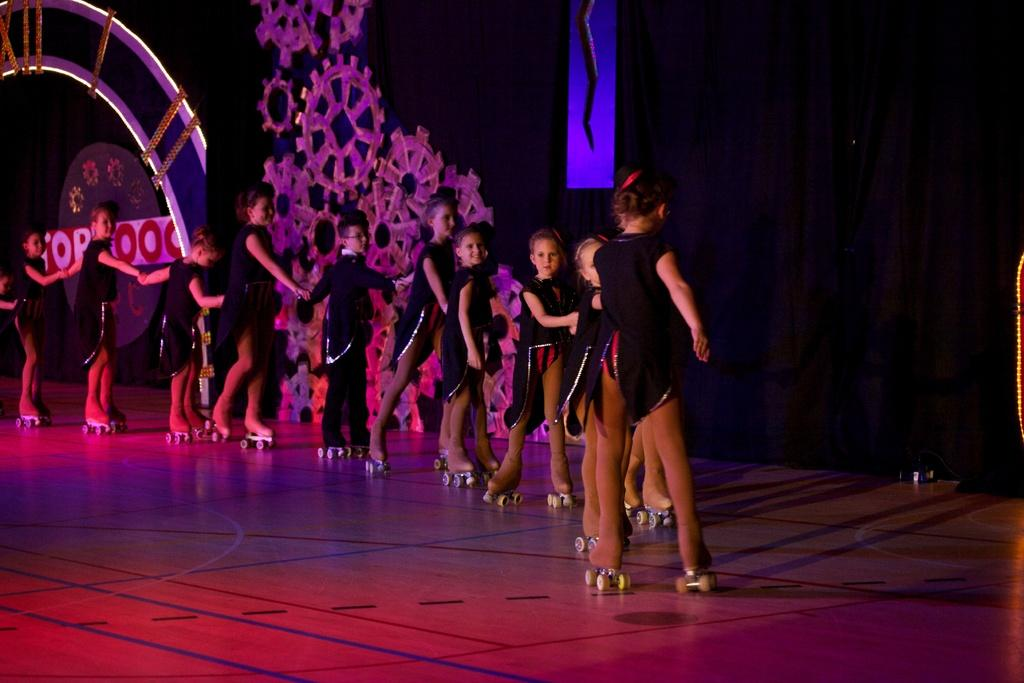What is the main subject of the image? The main subject of the image is a group of children. How are the children arranged in the image? The children are standing in a line. What are the children wearing in the image? The children are wearing black dresses and skate shoes. What can be inferred about the setting of the image? The setting appears to be a stage. What type of pipe can be seen in the background of the image? There is no pipe visible in the background of the image. What advice can be given to the children in the image? We cannot give advice to the children in the image, as it is a static photograph and we do not have any context about their situation or needs. 